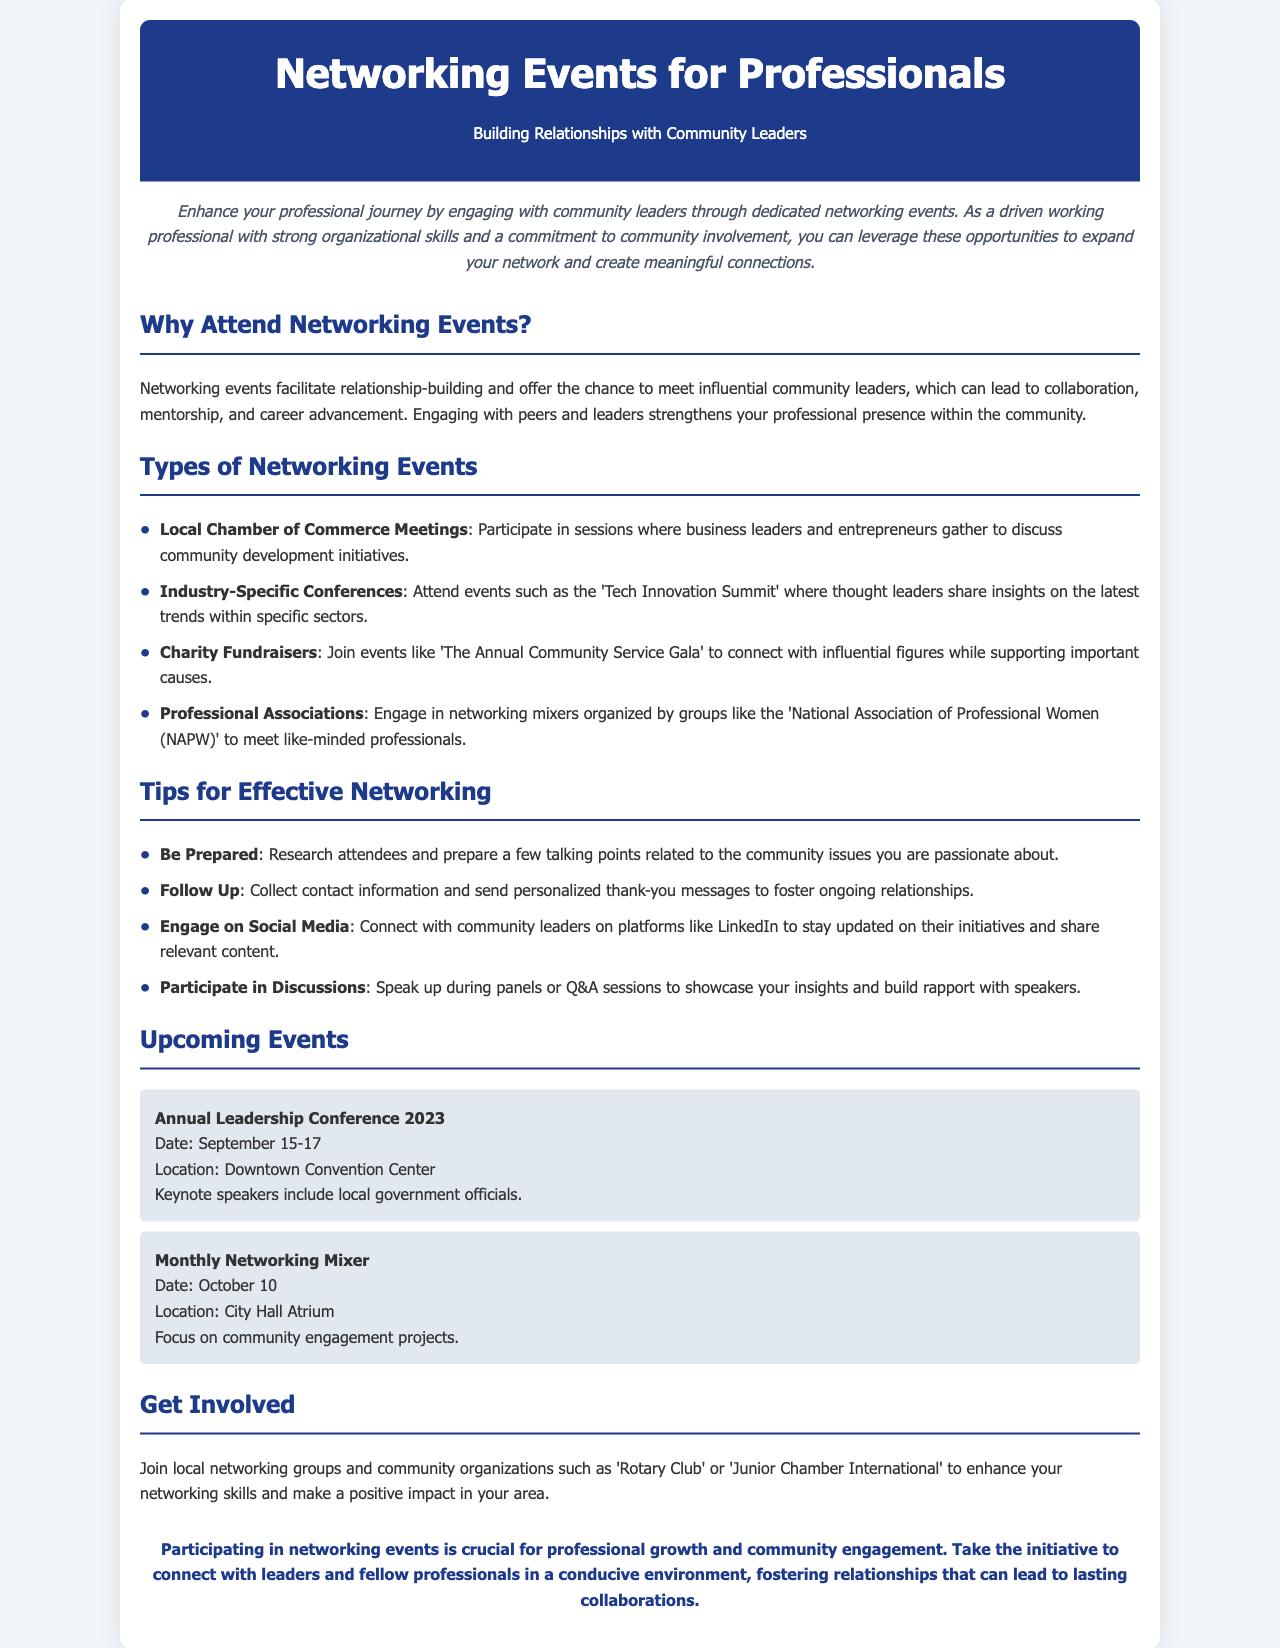What is the title of the brochure? The title clearly states the focus of the document, which is provided prominently at the beginning.
Answer: Networking Events for Professionals What are the dates for the Annual Leadership Conference 2023? Specific event dates are listed under the Upcoming Events section for clarity.
Answer: September 15-17 Which organization is mentioned for a Monthly Networking Mixer? The location for this specific event is stated to encourage attendance.
Answer: City Hall Atrium What is one type of networking event listed? Examples of events that promote professional networking are detailed for attendees' consideration.
Answer: Local Chamber of Commerce Meetings Name one tip for effective networking. Tips are provided to help attendees maximize their networking experiences, focusing on preparation.
Answer: Be Prepared What is emphasized as crucial for professional growth? The conclusion highlights the importance of a certain activity for career development.
Answer: Networking events What is the focus of the Monthly Networking Mixer? The theme of the event shows its purpose, which is described clearly in the document.
Answer: Community engagement projects What local group is suggested for involvement? The document recommends organizations that professionals can join to enhance their networking skills.
Answer: Rotary Club What color is used for headers? The document’s color scheme is mentioned, giving insight into its design aesthetic.
Answer: Dark blue (hex #1e3a8a) What should be done after collecting contact information? This follow-up action is suggested to maintain relationships established during networking.
Answer: Follow Up 